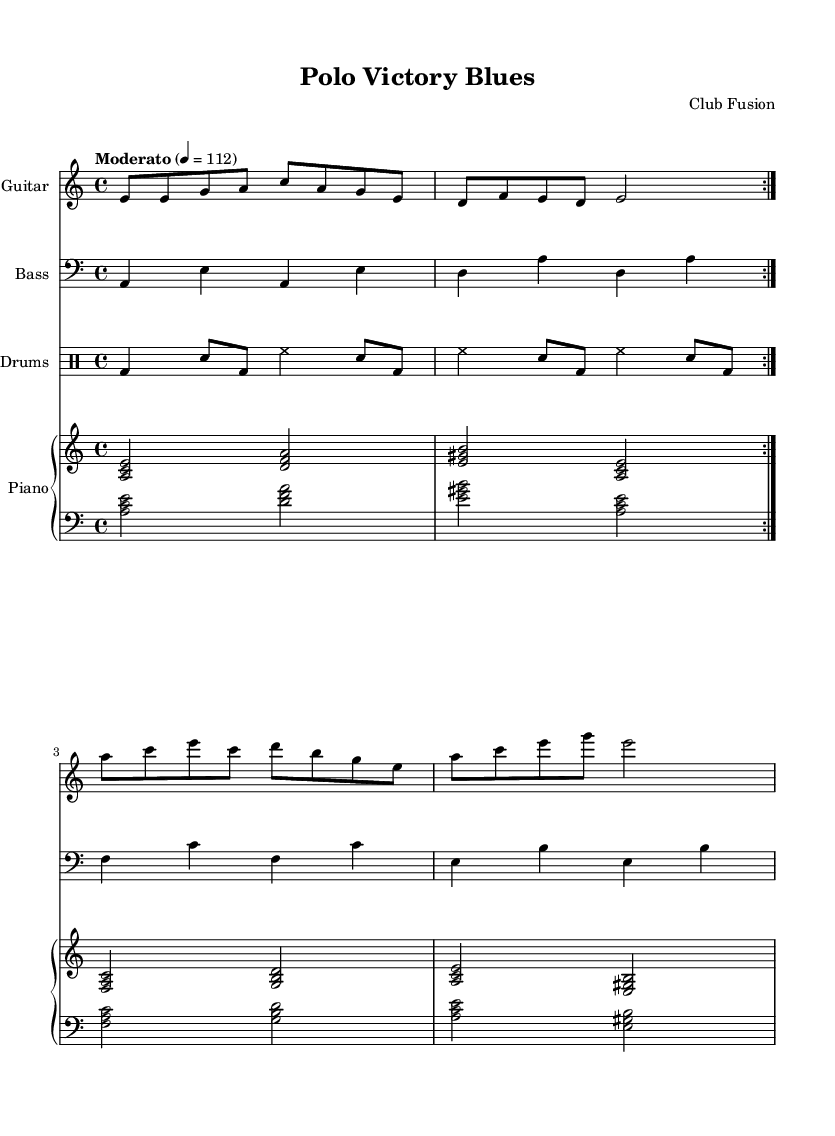What is the key signature of this music? The key signature is A minor, which is indicated by one sharp in its relative major, C major, and is derived from the absence of any sharps or flats in the staff's signature.
Answer: A minor What is the time signature of this music? The time signature is 4/4, which means there are four beats in a measure and the quarter note gets one beat, evident from the time signature label at the beginning of the score.
Answer: 4/4 What is the tempo marking for this piece? The tempo marking indicates that the piece should be played at a moderato tempo, specifically set at a metronome marking of 112 beats per minute, as shown at the beginning of the sheet music.
Answer: Moderato 4 = 112 How many times is the electric guitar part repeated? The electric guitar part has a repeated section indicated by the 'volta 2' marking, indicating that the preceding measures will be played two times.
Answer: 2 Which instruments are included in this composition? The composition includes Electric Guitar, Bass, Drums, and Piano, as indicated by the instrument names listed at the beginning of each staff in the score.
Answer: Electric Guitar, Bass, Drums, Piano What type of musical fusion is represented in this piece? The music demonstrates a fusion of Electric Blues with Latin rhythms, where the rhythmic and melodic elements intertwine typical of both styles, reflecting the celebratory context mentioned.
Answer: Electric Blues fusion with Latin rhythms What is a notable rhythmic element seen in the drumming section? The drumming section contains a characteristic rock beat consisting of bass drum and snare patterns, repeated through the volta sections, indicating a standard yet effective rhythmic approach for blues music.
Answer: Rock beat 